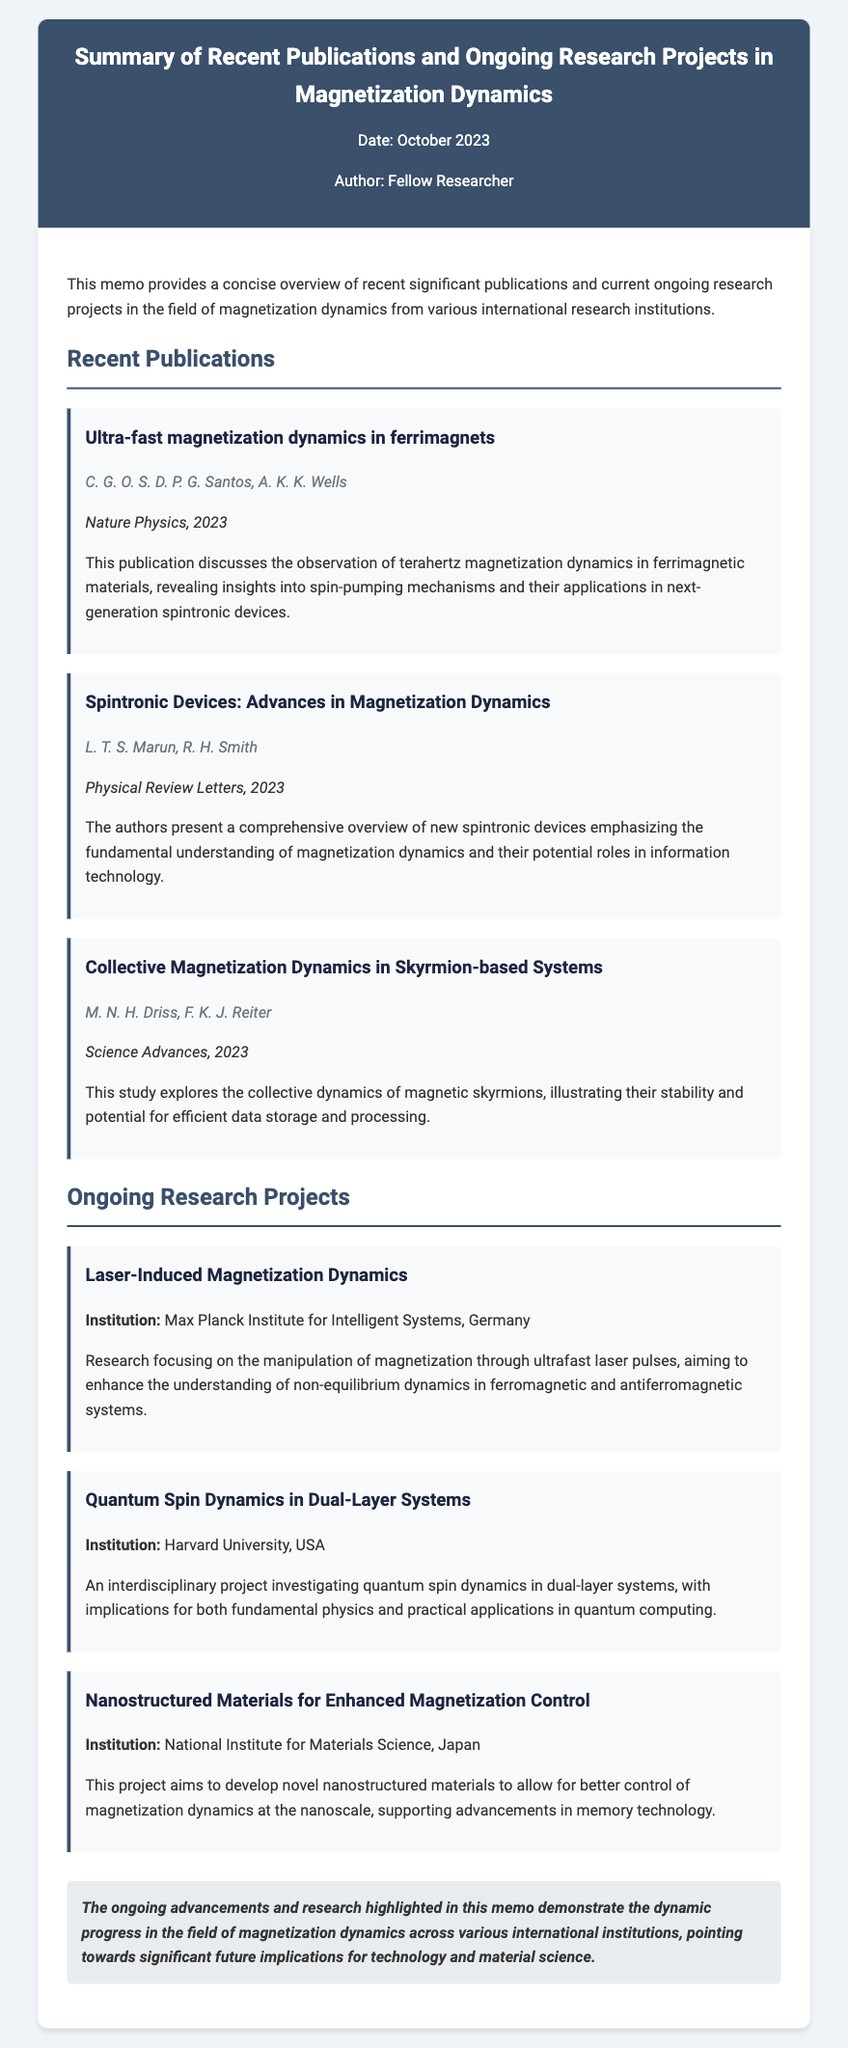what is the title of the first publication? The title of the first publication is the one listed under "Recent Publications," specifically "Ultra-fast magnetization dynamics in ferrimagnets."
Answer: Ultra-fast magnetization dynamics in ferrimagnets who are the authors of the second publication? The authors are listed under the title of the second publication, which is “Spintronic Devices: Advances in Magnetization Dynamics.”
Answer: L. T. S. Marun, R. H. Smith which journal published the third publication? The journal is mentioned after the title of the third publication, which is “Collective Magnetization Dynamics in Skyrmion-based Systems.”
Answer: Science Advances how many ongoing research projects are mentioned in the memo? The number is determined by counting the projects listed under "Ongoing Research Projects."
Answer: Three what is the focus of the project at the Max Planck Institute for Intelligent Systems? The focus can be found in the description for the project listed under that institution.
Answer: Manipulation of magnetization through ultrafast laser pulses which institution is conducting research on Quantum Spin Dynamics? This information is found under the “Quantum Spin Dynamics in Dual-Layer Systems” project.
Answer: Harvard University what is one application area discussed in the first publication? The application area can be inferred from the content of the first publication's description.
Answer: Spintronic devices what is the date of the memo? The date is provided in the header of the memo under the title.
Answer: October 2023 